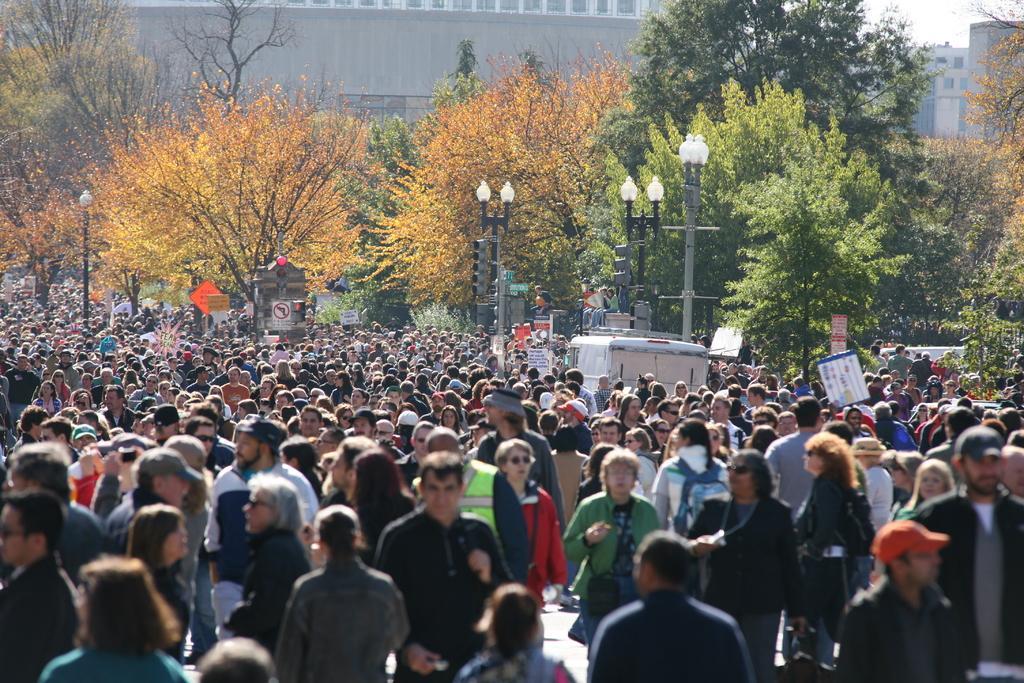How would you summarize this image in a sentence or two? In this picture we can observe many people walking. There were men and women in this picture. There are some poles and we can observe a white color vehicle. There are some trees. In the background there are buildings. 